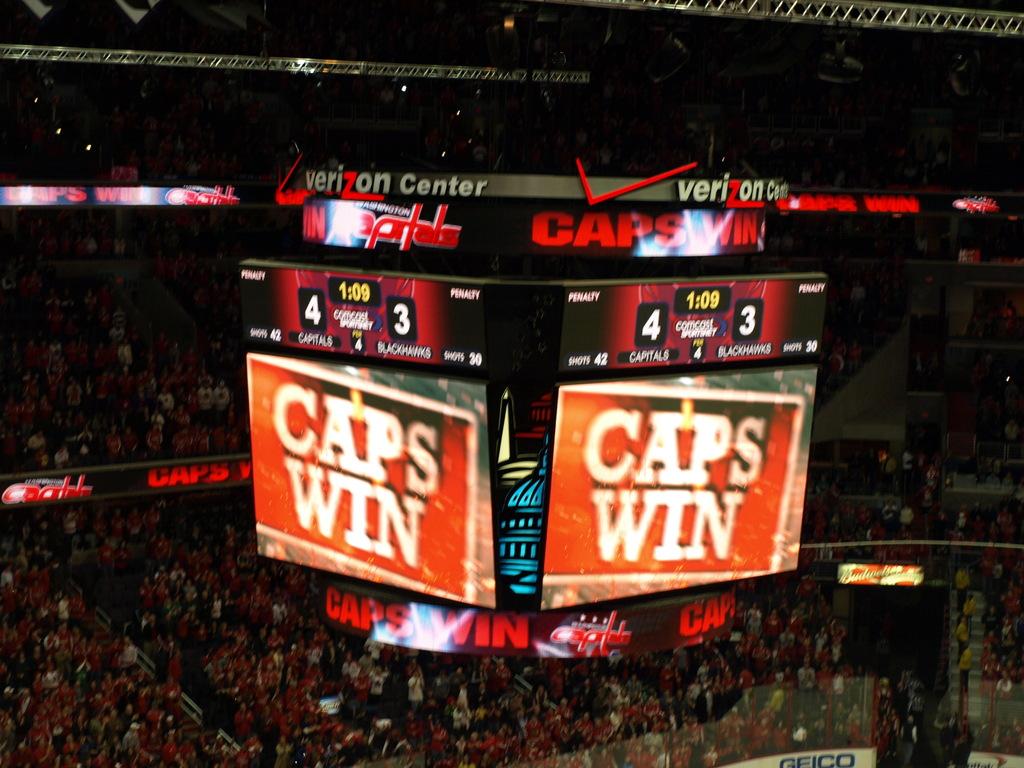What was the score?
Give a very brief answer. 4-3. 